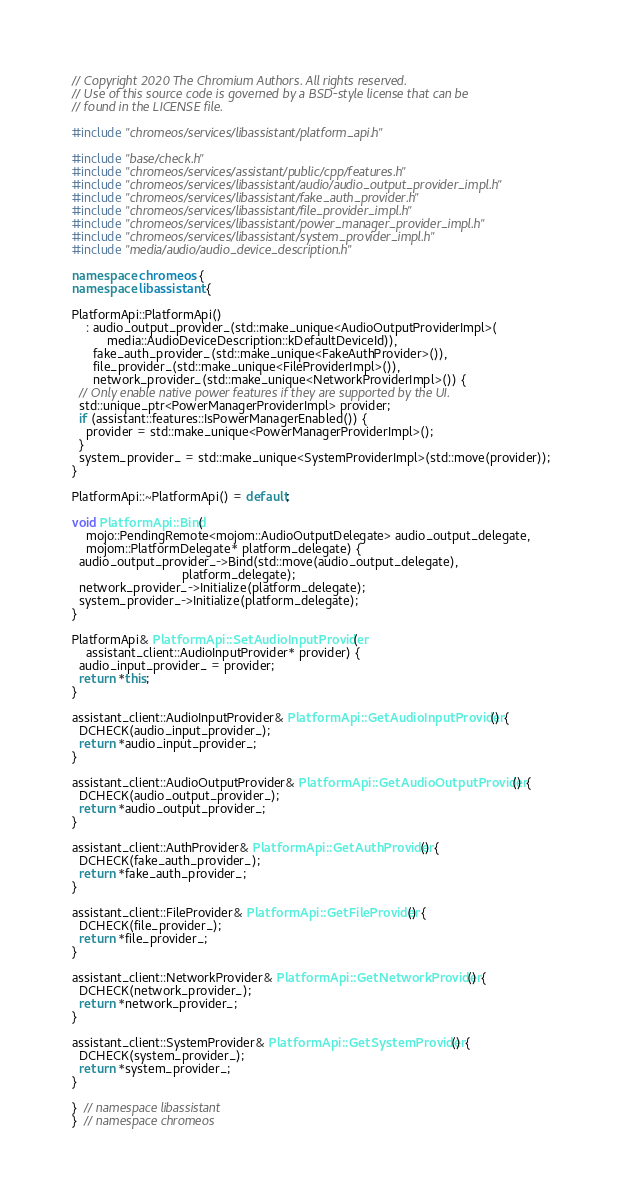<code> <loc_0><loc_0><loc_500><loc_500><_C++_>// Copyright 2020 The Chromium Authors. All rights reserved.
// Use of this source code is governed by a BSD-style license that can be
// found in the LICENSE file.

#include "chromeos/services/libassistant/platform_api.h"

#include "base/check.h"
#include "chromeos/services/assistant/public/cpp/features.h"
#include "chromeos/services/libassistant/audio/audio_output_provider_impl.h"
#include "chromeos/services/libassistant/fake_auth_provider.h"
#include "chromeos/services/libassistant/file_provider_impl.h"
#include "chromeos/services/libassistant/power_manager_provider_impl.h"
#include "chromeos/services/libassistant/system_provider_impl.h"
#include "media/audio/audio_device_description.h"

namespace chromeos {
namespace libassistant {

PlatformApi::PlatformApi()
    : audio_output_provider_(std::make_unique<AudioOutputProviderImpl>(
          media::AudioDeviceDescription::kDefaultDeviceId)),
      fake_auth_provider_(std::make_unique<FakeAuthProvider>()),
      file_provider_(std::make_unique<FileProviderImpl>()),
      network_provider_(std::make_unique<NetworkProviderImpl>()) {
  // Only enable native power features if they are supported by the UI.
  std::unique_ptr<PowerManagerProviderImpl> provider;
  if (assistant::features::IsPowerManagerEnabled()) {
    provider = std::make_unique<PowerManagerProviderImpl>();
  }
  system_provider_ = std::make_unique<SystemProviderImpl>(std::move(provider));
}

PlatformApi::~PlatformApi() = default;

void PlatformApi::Bind(
    mojo::PendingRemote<mojom::AudioOutputDelegate> audio_output_delegate,
    mojom::PlatformDelegate* platform_delegate) {
  audio_output_provider_->Bind(std::move(audio_output_delegate),
                               platform_delegate);
  network_provider_->Initialize(platform_delegate);
  system_provider_->Initialize(platform_delegate);
}

PlatformApi& PlatformApi::SetAudioInputProvider(
    assistant_client::AudioInputProvider* provider) {
  audio_input_provider_ = provider;
  return *this;
}

assistant_client::AudioInputProvider& PlatformApi::GetAudioInputProvider() {
  DCHECK(audio_input_provider_);
  return *audio_input_provider_;
}

assistant_client::AudioOutputProvider& PlatformApi::GetAudioOutputProvider() {
  DCHECK(audio_output_provider_);
  return *audio_output_provider_;
}

assistant_client::AuthProvider& PlatformApi::GetAuthProvider() {
  DCHECK(fake_auth_provider_);
  return *fake_auth_provider_;
}

assistant_client::FileProvider& PlatformApi::GetFileProvider() {
  DCHECK(file_provider_);
  return *file_provider_;
}

assistant_client::NetworkProvider& PlatformApi::GetNetworkProvider() {
  DCHECK(network_provider_);
  return *network_provider_;
}

assistant_client::SystemProvider& PlatformApi::GetSystemProvider() {
  DCHECK(system_provider_);
  return *system_provider_;
}

}  // namespace libassistant
}  // namespace chromeos
</code> 